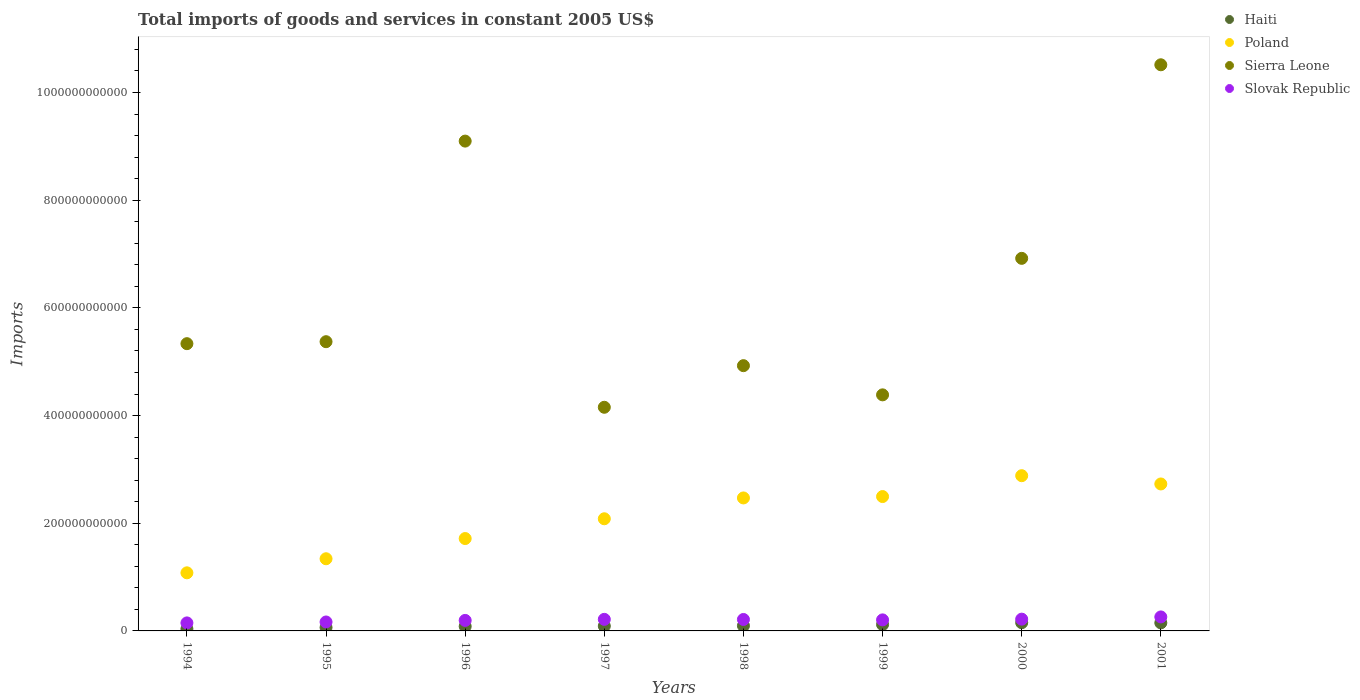What is the total imports of goods and services in Sierra Leone in 1994?
Offer a very short reply. 5.34e+11. Across all years, what is the maximum total imports of goods and services in Poland?
Provide a short and direct response. 2.88e+11. Across all years, what is the minimum total imports of goods and services in Poland?
Your answer should be compact. 1.08e+11. What is the total total imports of goods and services in Poland in the graph?
Provide a short and direct response. 1.68e+12. What is the difference between the total imports of goods and services in Poland in 1998 and that in 2000?
Give a very brief answer. -4.13e+1. What is the difference between the total imports of goods and services in Poland in 1998 and the total imports of goods and services in Slovak Republic in 2000?
Provide a succinct answer. 2.25e+11. What is the average total imports of goods and services in Slovak Republic per year?
Your answer should be compact. 2.03e+1. In the year 1999, what is the difference between the total imports of goods and services in Sierra Leone and total imports of goods and services in Haiti?
Make the answer very short. 4.27e+11. In how many years, is the total imports of goods and services in Slovak Republic greater than 440000000000 US$?
Make the answer very short. 0. What is the ratio of the total imports of goods and services in Poland in 1996 to that in 1997?
Make the answer very short. 0.82. Is the total imports of goods and services in Haiti in 1994 less than that in 1998?
Your answer should be very brief. Yes. What is the difference between the highest and the second highest total imports of goods and services in Poland?
Make the answer very short. 1.54e+1. What is the difference between the highest and the lowest total imports of goods and services in Poland?
Make the answer very short. 1.80e+11. Is it the case that in every year, the sum of the total imports of goods and services in Sierra Leone and total imports of goods and services in Haiti  is greater than the sum of total imports of goods and services in Poland and total imports of goods and services in Slovak Republic?
Offer a very short reply. Yes. Is it the case that in every year, the sum of the total imports of goods and services in Sierra Leone and total imports of goods and services in Poland  is greater than the total imports of goods and services in Slovak Republic?
Make the answer very short. Yes. Does the total imports of goods and services in Haiti monotonically increase over the years?
Provide a succinct answer. No. What is the difference between two consecutive major ticks on the Y-axis?
Offer a terse response. 2.00e+11. Does the graph contain any zero values?
Make the answer very short. No. Does the graph contain grids?
Keep it short and to the point. No. What is the title of the graph?
Make the answer very short. Total imports of goods and services in constant 2005 US$. Does "Canada" appear as one of the legend labels in the graph?
Provide a short and direct response. No. What is the label or title of the X-axis?
Your response must be concise. Years. What is the label or title of the Y-axis?
Ensure brevity in your answer.  Imports. What is the Imports in Haiti in 1994?
Offer a terse response. 3.75e+09. What is the Imports of Poland in 1994?
Ensure brevity in your answer.  1.08e+11. What is the Imports of Sierra Leone in 1994?
Provide a succinct answer. 5.34e+11. What is the Imports of Slovak Republic in 1994?
Give a very brief answer. 1.49e+1. What is the Imports in Haiti in 1995?
Make the answer very short. 6.34e+09. What is the Imports in Poland in 1995?
Your answer should be compact. 1.34e+11. What is the Imports of Sierra Leone in 1995?
Ensure brevity in your answer.  5.37e+11. What is the Imports in Slovak Republic in 1995?
Offer a terse response. 1.66e+1. What is the Imports in Haiti in 1996?
Keep it short and to the point. 8.41e+09. What is the Imports in Poland in 1996?
Ensure brevity in your answer.  1.72e+11. What is the Imports of Sierra Leone in 1996?
Provide a succinct answer. 9.10e+11. What is the Imports in Slovak Republic in 1996?
Provide a succinct answer. 1.95e+1. What is the Imports in Haiti in 1997?
Make the answer very short. 9.02e+09. What is the Imports in Poland in 1997?
Ensure brevity in your answer.  2.08e+11. What is the Imports in Sierra Leone in 1997?
Your answer should be very brief. 4.15e+11. What is the Imports in Slovak Republic in 1997?
Ensure brevity in your answer.  2.15e+1. What is the Imports in Haiti in 1998?
Offer a very short reply. 9.61e+09. What is the Imports of Poland in 1998?
Your answer should be compact. 2.47e+11. What is the Imports of Sierra Leone in 1998?
Offer a terse response. 4.93e+11. What is the Imports in Slovak Republic in 1998?
Ensure brevity in your answer.  2.13e+1. What is the Imports of Haiti in 1999?
Provide a short and direct response. 1.18e+1. What is the Imports of Poland in 1999?
Your response must be concise. 2.50e+11. What is the Imports of Sierra Leone in 1999?
Give a very brief answer. 4.38e+11. What is the Imports in Slovak Republic in 1999?
Keep it short and to the point. 2.05e+1. What is the Imports in Haiti in 2000?
Provide a short and direct response. 1.52e+1. What is the Imports in Poland in 2000?
Your response must be concise. 2.88e+11. What is the Imports in Sierra Leone in 2000?
Give a very brief answer. 6.92e+11. What is the Imports in Slovak Republic in 2000?
Give a very brief answer. 2.19e+1. What is the Imports of Haiti in 2001?
Your answer should be very brief. 1.49e+1. What is the Imports of Poland in 2001?
Offer a very short reply. 2.73e+11. What is the Imports in Sierra Leone in 2001?
Your answer should be very brief. 1.05e+12. What is the Imports of Slovak Republic in 2001?
Keep it short and to the point. 2.60e+1. Across all years, what is the maximum Imports of Haiti?
Offer a very short reply. 1.52e+1. Across all years, what is the maximum Imports of Poland?
Your answer should be very brief. 2.88e+11. Across all years, what is the maximum Imports in Sierra Leone?
Provide a short and direct response. 1.05e+12. Across all years, what is the maximum Imports of Slovak Republic?
Give a very brief answer. 2.60e+1. Across all years, what is the minimum Imports of Haiti?
Keep it short and to the point. 3.75e+09. Across all years, what is the minimum Imports in Poland?
Give a very brief answer. 1.08e+11. Across all years, what is the minimum Imports in Sierra Leone?
Your answer should be very brief. 4.15e+11. Across all years, what is the minimum Imports in Slovak Republic?
Offer a terse response. 1.49e+1. What is the total Imports in Haiti in the graph?
Your response must be concise. 7.91e+1. What is the total Imports of Poland in the graph?
Make the answer very short. 1.68e+12. What is the total Imports of Sierra Leone in the graph?
Offer a terse response. 5.07e+12. What is the total Imports of Slovak Republic in the graph?
Your answer should be compact. 1.62e+11. What is the difference between the Imports in Haiti in 1994 and that in 1995?
Your answer should be very brief. -2.59e+09. What is the difference between the Imports of Poland in 1994 and that in 1995?
Provide a short and direct response. -2.61e+1. What is the difference between the Imports of Sierra Leone in 1994 and that in 1995?
Ensure brevity in your answer.  -3.67e+09. What is the difference between the Imports of Slovak Republic in 1994 and that in 1995?
Your answer should be very brief. -1.73e+09. What is the difference between the Imports in Haiti in 1994 and that in 1996?
Your answer should be compact. -4.66e+09. What is the difference between the Imports in Poland in 1994 and that in 1996?
Your answer should be very brief. -6.37e+1. What is the difference between the Imports in Sierra Leone in 1994 and that in 1996?
Give a very brief answer. -3.76e+11. What is the difference between the Imports in Slovak Republic in 1994 and that in 1996?
Ensure brevity in your answer.  -4.65e+09. What is the difference between the Imports of Haiti in 1994 and that in 1997?
Your answer should be compact. -5.27e+09. What is the difference between the Imports in Poland in 1994 and that in 1997?
Keep it short and to the point. -1.00e+11. What is the difference between the Imports in Sierra Leone in 1994 and that in 1997?
Your answer should be compact. 1.18e+11. What is the difference between the Imports of Slovak Republic in 1994 and that in 1997?
Offer a very short reply. -6.63e+09. What is the difference between the Imports in Haiti in 1994 and that in 1998?
Offer a very short reply. -5.86e+09. What is the difference between the Imports in Poland in 1994 and that in 1998?
Offer a very short reply. -1.39e+11. What is the difference between the Imports in Sierra Leone in 1994 and that in 1998?
Provide a succinct answer. 4.09e+1. What is the difference between the Imports of Slovak Republic in 1994 and that in 1998?
Keep it short and to the point. -6.39e+09. What is the difference between the Imports in Haiti in 1994 and that in 1999?
Offer a terse response. -8.05e+09. What is the difference between the Imports of Poland in 1994 and that in 1999?
Provide a succinct answer. -1.42e+11. What is the difference between the Imports of Sierra Leone in 1994 and that in 1999?
Your answer should be very brief. 9.51e+1. What is the difference between the Imports of Slovak Republic in 1994 and that in 1999?
Keep it short and to the point. -5.63e+09. What is the difference between the Imports in Haiti in 1994 and that in 2000?
Keep it short and to the point. -1.15e+1. What is the difference between the Imports of Poland in 1994 and that in 2000?
Make the answer very short. -1.80e+11. What is the difference between the Imports in Sierra Leone in 1994 and that in 2000?
Your answer should be compact. -1.58e+11. What is the difference between the Imports of Slovak Republic in 1994 and that in 2000?
Give a very brief answer. -6.99e+09. What is the difference between the Imports in Haiti in 1994 and that in 2001?
Your response must be concise. -1.12e+1. What is the difference between the Imports of Poland in 1994 and that in 2001?
Provide a short and direct response. -1.65e+11. What is the difference between the Imports in Sierra Leone in 1994 and that in 2001?
Provide a succinct answer. -5.18e+11. What is the difference between the Imports of Slovak Republic in 1994 and that in 2001?
Offer a very short reply. -1.11e+1. What is the difference between the Imports in Haiti in 1995 and that in 1996?
Make the answer very short. -2.07e+09. What is the difference between the Imports in Poland in 1995 and that in 1996?
Ensure brevity in your answer.  -3.75e+1. What is the difference between the Imports of Sierra Leone in 1995 and that in 1996?
Give a very brief answer. -3.73e+11. What is the difference between the Imports in Slovak Republic in 1995 and that in 1996?
Provide a succinct answer. -2.92e+09. What is the difference between the Imports in Haiti in 1995 and that in 1997?
Your answer should be very brief. -2.67e+09. What is the difference between the Imports of Poland in 1995 and that in 1997?
Ensure brevity in your answer.  -7.43e+1. What is the difference between the Imports in Sierra Leone in 1995 and that in 1997?
Provide a succinct answer. 1.22e+11. What is the difference between the Imports of Slovak Republic in 1995 and that in 1997?
Provide a succinct answer. -4.90e+09. What is the difference between the Imports in Haiti in 1995 and that in 1998?
Your answer should be very brief. -3.27e+09. What is the difference between the Imports in Poland in 1995 and that in 1998?
Make the answer very short. -1.13e+11. What is the difference between the Imports of Sierra Leone in 1995 and that in 1998?
Make the answer very short. 4.45e+1. What is the difference between the Imports of Slovak Republic in 1995 and that in 1998?
Ensure brevity in your answer.  -4.66e+09. What is the difference between the Imports of Haiti in 1995 and that in 1999?
Provide a short and direct response. -5.45e+09. What is the difference between the Imports in Poland in 1995 and that in 1999?
Your answer should be very brief. -1.16e+11. What is the difference between the Imports of Sierra Leone in 1995 and that in 1999?
Keep it short and to the point. 9.87e+1. What is the difference between the Imports of Slovak Republic in 1995 and that in 1999?
Offer a very short reply. -3.90e+09. What is the difference between the Imports in Haiti in 1995 and that in 2000?
Provide a short and direct response. -8.90e+09. What is the difference between the Imports in Poland in 1995 and that in 2000?
Your response must be concise. -1.54e+11. What is the difference between the Imports of Sierra Leone in 1995 and that in 2000?
Offer a terse response. -1.55e+11. What is the difference between the Imports in Slovak Republic in 1995 and that in 2000?
Offer a very short reply. -5.26e+09. What is the difference between the Imports in Haiti in 1995 and that in 2001?
Provide a short and direct response. -8.59e+09. What is the difference between the Imports in Poland in 1995 and that in 2001?
Make the answer very short. -1.39e+11. What is the difference between the Imports of Sierra Leone in 1995 and that in 2001?
Ensure brevity in your answer.  -5.14e+11. What is the difference between the Imports in Slovak Republic in 1995 and that in 2001?
Offer a very short reply. -9.40e+09. What is the difference between the Imports of Haiti in 1996 and that in 1997?
Offer a very short reply. -6.07e+08. What is the difference between the Imports of Poland in 1996 and that in 1997?
Give a very brief answer. -3.67e+1. What is the difference between the Imports of Sierra Leone in 1996 and that in 1997?
Your answer should be very brief. 4.94e+11. What is the difference between the Imports of Slovak Republic in 1996 and that in 1997?
Your answer should be very brief. -1.98e+09. What is the difference between the Imports in Haiti in 1996 and that in 1998?
Give a very brief answer. -1.20e+09. What is the difference between the Imports in Poland in 1996 and that in 1998?
Provide a short and direct response. -7.54e+1. What is the difference between the Imports in Sierra Leone in 1996 and that in 1998?
Keep it short and to the point. 4.17e+11. What is the difference between the Imports of Slovak Republic in 1996 and that in 1998?
Ensure brevity in your answer.  -1.74e+09. What is the difference between the Imports of Haiti in 1996 and that in 1999?
Provide a succinct answer. -3.38e+09. What is the difference between the Imports in Poland in 1996 and that in 1999?
Your response must be concise. -7.80e+1. What is the difference between the Imports of Sierra Leone in 1996 and that in 1999?
Your answer should be very brief. 4.71e+11. What is the difference between the Imports of Slovak Republic in 1996 and that in 1999?
Your response must be concise. -9.83e+08. What is the difference between the Imports of Haiti in 1996 and that in 2000?
Provide a succinct answer. -6.84e+09. What is the difference between the Imports of Poland in 1996 and that in 2000?
Offer a very short reply. -1.17e+11. What is the difference between the Imports of Sierra Leone in 1996 and that in 2000?
Provide a succinct answer. 2.18e+11. What is the difference between the Imports of Slovak Republic in 1996 and that in 2000?
Your answer should be compact. -2.34e+09. What is the difference between the Imports in Haiti in 1996 and that in 2001?
Keep it short and to the point. -6.52e+09. What is the difference between the Imports of Poland in 1996 and that in 2001?
Offer a very short reply. -1.01e+11. What is the difference between the Imports in Sierra Leone in 1996 and that in 2001?
Keep it short and to the point. -1.42e+11. What is the difference between the Imports of Slovak Republic in 1996 and that in 2001?
Your answer should be very brief. -6.48e+09. What is the difference between the Imports of Haiti in 1997 and that in 1998?
Your response must be concise. -5.95e+08. What is the difference between the Imports of Poland in 1997 and that in 1998?
Your answer should be very brief. -3.87e+1. What is the difference between the Imports in Sierra Leone in 1997 and that in 1998?
Offer a terse response. -7.73e+1. What is the difference between the Imports in Slovak Republic in 1997 and that in 1998?
Ensure brevity in your answer.  2.36e+08. What is the difference between the Imports of Haiti in 1997 and that in 1999?
Your answer should be very brief. -2.78e+09. What is the difference between the Imports in Poland in 1997 and that in 1999?
Ensure brevity in your answer.  -4.13e+1. What is the difference between the Imports in Sierra Leone in 1997 and that in 1999?
Offer a terse response. -2.31e+1. What is the difference between the Imports of Slovak Republic in 1997 and that in 1999?
Provide a succinct answer. 9.95e+08. What is the difference between the Imports in Haiti in 1997 and that in 2000?
Provide a succinct answer. -6.23e+09. What is the difference between the Imports of Poland in 1997 and that in 2000?
Offer a very short reply. -8.00e+1. What is the difference between the Imports in Sierra Leone in 1997 and that in 2000?
Provide a short and direct response. -2.77e+11. What is the difference between the Imports of Slovak Republic in 1997 and that in 2000?
Make the answer very short. -3.59e+08. What is the difference between the Imports in Haiti in 1997 and that in 2001?
Provide a succinct answer. -5.91e+09. What is the difference between the Imports in Poland in 1997 and that in 2001?
Provide a succinct answer. -6.46e+1. What is the difference between the Imports of Sierra Leone in 1997 and that in 2001?
Your answer should be very brief. -6.36e+11. What is the difference between the Imports of Slovak Republic in 1997 and that in 2001?
Your response must be concise. -4.50e+09. What is the difference between the Imports of Haiti in 1998 and that in 1999?
Your answer should be compact. -2.18e+09. What is the difference between the Imports of Poland in 1998 and that in 1999?
Keep it short and to the point. -2.57e+09. What is the difference between the Imports in Sierra Leone in 1998 and that in 1999?
Give a very brief answer. 5.42e+1. What is the difference between the Imports in Slovak Republic in 1998 and that in 1999?
Give a very brief answer. 7.59e+08. What is the difference between the Imports of Haiti in 1998 and that in 2000?
Ensure brevity in your answer.  -5.64e+09. What is the difference between the Imports of Poland in 1998 and that in 2000?
Ensure brevity in your answer.  -4.13e+1. What is the difference between the Imports of Sierra Leone in 1998 and that in 2000?
Your response must be concise. -1.99e+11. What is the difference between the Imports of Slovak Republic in 1998 and that in 2000?
Give a very brief answer. -5.95e+08. What is the difference between the Imports in Haiti in 1998 and that in 2001?
Your response must be concise. -5.32e+09. What is the difference between the Imports in Poland in 1998 and that in 2001?
Give a very brief answer. -2.60e+1. What is the difference between the Imports of Sierra Leone in 1998 and that in 2001?
Make the answer very short. -5.59e+11. What is the difference between the Imports in Slovak Republic in 1998 and that in 2001?
Your answer should be very brief. -4.74e+09. What is the difference between the Imports of Haiti in 1999 and that in 2000?
Keep it short and to the point. -3.45e+09. What is the difference between the Imports in Poland in 1999 and that in 2000?
Provide a succinct answer. -3.87e+1. What is the difference between the Imports of Sierra Leone in 1999 and that in 2000?
Provide a succinct answer. -2.54e+11. What is the difference between the Imports in Slovak Republic in 1999 and that in 2000?
Your answer should be very brief. -1.35e+09. What is the difference between the Imports of Haiti in 1999 and that in 2001?
Offer a very short reply. -3.14e+09. What is the difference between the Imports in Poland in 1999 and that in 2001?
Offer a very short reply. -2.34e+1. What is the difference between the Imports in Sierra Leone in 1999 and that in 2001?
Give a very brief answer. -6.13e+11. What is the difference between the Imports of Slovak Republic in 1999 and that in 2001?
Your answer should be compact. -5.50e+09. What is the difference between the Imports of Haiti in 2000 and that in 2001?
Ensure brevity in your answer.  3.17e+08. What is the difference between the Imports in Poland in 2000 and that in 2001?
Give a very brief answer. 1.54e+1. What is the difference between the Imports in Sierra Leone in 2000 and that in 2001?
Make the answer very short. -3.60e+11. What is the difference between the Imports in Slovak Republic in 2000 and that in 2001?
Provide a short and direct response. -4.14e+09. What is the difference between the Imports in Haiti in 1994 and the Imports in Poland in 1995?
Give a very brief answer. -1.30e+11. What is the difference between the Imports of Haiti in 1994 and the Imports of Sierra Leone in 1995?
Provide a succinct answer. -5.33e+11. What is the difference between the Imports in Haiti in 1994 and the Imports in Slovak Republic in 1995?
Ensure brevity in your answer.  -1.29e+1. What is the difference between the Imports of Poland in 1994 and the Imports of Sierra Leone in 1995?
Make the answer very short. -4.29e+11. What is the difference between the Imports of Poland in 1994 and the Imports of Slovak Republic in 1995?
Keep it short and to the point. 9.13e+1. What is the difference between the Imports of Sierra Leone in 1994 and the Imports of Slovak Republic in 1995?
Your answer should be very brief. 5.17e+11. What is the difference between the Imports of Haiti in 1994 and the Imports of Poland in 1996?
Ensure brevity in your answer.  -1.68e+11. What is the difference between the Imports of Haiti in 1994 and the Imports of Sierra Leone in 1996?
Provide a short and direct response. -9.06e+11. What is the difference between the Imports in Haiti in 1994 and the Imports in Slovak Republic in 1996?
Offer a very short reply. -1.58e+1. What is the difference between the Imports in Poland in 1994 and the Imports in Sierra Leone in 1996?
Offer a very short reply. -8.02e+11. What is the difference between the Imports of Poland in 1994 and the Imports of Slovak Republic in 1996?
Your answer should be very brief. 8.84e+1. What is the difference between the Imports in Sierra Leone in 1994 and the Imports in Slovak Republic in 1996?
Your response must be concise. 5.14e+11. What is the difference between the Imports of Haiti in 1994 and the Imports of Poland in 1997?
Offer a very short reply. -2.05e+11. What is the difference between the Imports of Haiti in 1994 and the Imports of Sierra Leone in 1997?
Your answer should be compact. -4.12e+11. What is the difference between the Imports in Haiti in 1994 and the Imports in Slovak Republic in 1997?
Keep it short and to the point. -1.77e+1. What is the difference between the Imports of Poland in 1994 and the Imports of Sierra Leone in 1997?
Your answer should be compact. -3.07e+11. What is the difference between the Imports in Poland in 1994 and the Imports in Slovak Republic in 1997?
Your response must be concise. 8.64e+1. What is the difference between the Imports of Sierra Leone in 1994 and the Imports of Slovak Republic in 1997?
Your response must be concise. 5.12e+11. What is the difference between the Imports in Haiti in 1994 and the Imports in Poland in 1998?
Provide a short and direct response. -2.43e+11. What is the difference between the Imports in Haiti in 1994 and the Imports in Sierra Leone in 1998?
Offer a terse response. -4.89e+11. What is the difference between the Imports in Haiti in 1994 and the Imports in Slovak Republic in 1998?
Your response must be concise. -1.75e+1. What is the difference between the Imports of Poland in 1994 and the Imports of Sierra Leone in 1998?
Your answer should be compact. -3.85e+11. What is the difference between the Imports of Poland in 1994 and the Imports of Slovak Republic in 1998?
Give a very brief answer. 8.66e+1. What is the difference between the Imports of Sierra Leone in 1994 and the Imports of Slovak Republic in 1998?
Provide a succinct answer. 5.12e+11. What is the difference between the Imports of Haiti in 1994 and the Imports of Poland in 1999?
Ensure brevity in your answer.  -2.46e+11. What is the difference between the Imports in Haiti in 1994 and the Imports in Sierra Leone in 1999?
Give a very brief answer. -4.35e+11. What is the difference between the Imports in Haiti in 1994 and the Imports in Slovak Republic in 1999?
Your response must be concise. -1.68e+1. What is the difference between the Imports of Poland in 1994 and the Imports of Sierra Leone in 1999?
Offer a very short reply. -3.31e+11. What is the difference between the Imports in Poland in 1994 and the Imports in Slovak Republic in 1999?
Provide a succinct answer. 8.74e+1. What is the difference between the Imports of Sierra Leone in 1994 and the Imports of Slovak Republic in 1999?
Your answer should be compact. 5.13e+11. What is the difference between the Imports in Haiti in 1994 and the Imports in Poland in 2000?
Give a very brief answer. -2.85e+11. What is the difference between the Imports of Haiti in 1994 and the Imports of Sierra Leone in 2000?
Offer a terse response. -6.88e+11. What is the difference between the Imports of Haiti in 1994 and the Imports of Slovak Republic in 2000?
Offer a very short reply. -1.81e+1. What is the difference between the Imports of Poland in 1994 and the Imports of Sierra Leone in 2000?
Give a very brief answer. -5.84e+11. What is the difference between the Imports in Poland in 1994 and the Imports in Slovak Republic in 2000?
Offer a very short reply. 8.60e+1. What is the difference between the Imports in Sierra Leone in 1994 and the Imports in Slovak Republic in 2000?
Offer a terse response. 5.12e+11. What is the difference between the Imports of Haiti in 1994 and the Imports of Poland in 2001?
Your answer should be very brief. -2.69e+11. What is the difference between the Imports in Haiti in 1994 and the Imports in Sierra Leone in 2001?
Offer a very short reply. -1.05e+12. What is the difference between the Imports of Haiti in 1994 and the Imports of Slovak Republic in 2001?
Your response must be concise. -2.22e+1. What is the difference between the Imports of Poland in 1994 and the Imports of Sierra Leone in 2001?
Offer a very short reply. -9.44e+11. What is the difference between the Imports in Poland in 1994 and the Imports in Slovak Republic in 2001?
Provide a succinct answer. 8.19e+1. What is the difference between the Imports of Sierra Leone in 1994 and the Imports of Slovak Republic in 2001?
Provide a short and direct response. 5.08e+11. What is the difference between the Imports in Haiti in 1995 and the Imports in Poland in 1996?
Give a very brief answer. -1.65e+11. What is the difference between the Imports of Haiti in 1995 and the Imports of Sierra Leone in 1996?
Ensure brevity in your answer.  -9.03e+11. What is the difference between the Imports of Haiti in 1995 and the Imports of Slovak Republic in 1996?
Offer a very short reply. -1.32e+1. What is the difference between the Imports of Poland in 1995 and the Imports of Sierra Leone in 1996?
Make the answer very short. -7.76e+11. What is the difference between the Imports in Poland in 1995 and the Imports in Slovak Republic in 1996?
Offer a terse response. 1.15e+11. What is the difference between the Imports in Sierra Leone in 1995 and the Imports in Slovak Republic in 1996?
Offer a terse response. 5.18e+11. What is the difference between the Imports of Haiti in 1995 and the Imports of Poland in 1997?
Your answer should be compact. -2.02e+11. What is the difference between the Imports of Haiti in 1995 and the Imports of Sierra Leone in 1997?
Provide a short and direct response. -4.09e+11. What is the difference between the Imports in Haiti in 1995 and the Imports in Slovak Republic in 1997?
Give a very brief answer. -1.52e+1. What is the difference between the Imports of Poland in 1995 and the Imports of Sierra Leone in 1997?
Provide a short and direct response. -2.81e+11. What is the difference between the Imports of Poland in 1995 and the Imports of Slovak Republic in 1997?
Provide a succinct answer. 1.13e+11. What is the difference between the Imports of Sierra Leone in 1995 and the Imports of Slovak Republic in 1997?
Your response must be concise. 5.16e+11. What is the difference between the Imports of Haiti in 1995 and the Imports of Poland in 1998?
Provide a short and direct response. -2.41e+11. What is the difference between the Imports in Haiti in 1995 and the Imports in Sierra Leone in 1998?
Ensure brevity in your answer.  -4.86e+11. What is the difference between the Imports of Haiti in 1995 and the Imports of Slovak Republic in 1998?
Keep it short and to the point. -1.49e+1. What is the difference between the Imports in Poland in 1995 and the Imports in Sierra Leone in 1998?
Your response must be concise. -3.59e+11. What is the difference between the Imports in Poland in 1995 and the Imports in Slovak Republic in 1998?
Your answer should be very brief. 1.13e+11. What is the difference between the Imports in Sierra Leone in 1995 and the Imports in Slovak Republic in 1998?
Ensure brevity in your answer.  5.16e+11. What is the difference between the Imports of Haiti in 1995 and the Imports of Poland in 1999?
Provide a short and direct response. -2.43e+11. What is the difference between the Imports in Haiti in 1995 and the Imports in Sierra Leone in 1999?
Give a very brief answer. -4.32e+11. What is the difference between the Imports of Haiti in 1995 and the Imports of Slovak Republic in 1999?
Offer a terse response. -1.42e+1. What is the difference between the Imports in Poland in 1995 and the Imports in Sierra Leone in 1999?
Give a very brief answer. -3.04e+11. What is the difference between the Imports in Poland in 1995 and the Imports in Slovak Republic in 1999?
Offer a terse response. 1.14e+11. What is the difference between the Imports in Sierra Leone in 1995 and the Imports in Slovak Republic in 1999?
Provide a short and direct response. 5.17e+11. What is the difference between the Imports of Haiti in 1995 and the Imports of Poland in 2000?
Give a very brief answer. -2.82e+11. What is the difference between the Imports in Haiti in 1995 and the Imports in Sierra Leone in 2000?
Your answer should be compact. -6.86e+11. What is the difference between the Imports in Haiti in 1995 and the Imports in Slovak Republic in 2000?
Give a very brief answer. -1.55e+1. What is the difference between the Imports in Poland in 1995 and the Imports in Sierra Leone in 2000?
Offer a very short reply. -5.58e+11. What is the difference between the Imports in Poland in 1995 and the Imports in Slovak Republic in 2000?
Provide a succinct answer. 1.12e+11. What is the difference between the Imports in Sierra Leone in 1995 and the Imports in Slovak Republic in 2000?
Your answer should be compact. 5.15e+11. What is the difference between the Imports in Haiti in 1995 and the Imports in Poland in 2001?
Provide a succinct answer. -2.67e+11. What is the difference between the Imports of Haiti in 1995 and the Imports of Sierra Leone in 2001?
Keep it short and to the point. -1.05e+12. What is the difference between the Imports of Haiti in 1995 and the Imports of Slovak Republic in 2001?
Ensure brevity in your answer.  -1.97e+1. What is the difference between the Imports in Poland in 1995 and the Imports in Sierra Leone in 2001?
Keep it short and to the point. -9.17e+11. What is the difference between the Imports of Poland in 1995 and the Imports of Slovak Republic in 2001?
Ensure brevity in your answer.  1.08e+11. What is the difference between the Imports in Sierra Leone in 1995 and the Imports in Slovak Republic in 2001?
Make the answer very short. 5.11e+11. What is the difference between the Imports in Haiti in 1996 and the Imports in Poland in 1997?
Offer a very short reply. -2.00e+11. What is the difference between the Imports in Haiti in 1996 and the Imports in Sierra Leone in 1997?
Your response must be concise. -4.07e+11. What is the difference between the Imports of Haiti in 1996 and the Imports of Slovak Republic in 1997?
Your answer should be compact. -1.31e+1. What is the difference between the Imports in Poland in 1996 and the Imports in Sierra Leone in 1997?
Provide a short and direct response. -2.44e+11. What is the difference between the Imports of Poland in 1996 and the Imports of Slovak Republic in 1997?
Your answer should be compact. 1.50e+11. What is the difference between the Imports of Sierra Leone in 1996 and the Imports of Slovak Republic in 1997?
Your response must be concise. 8.88e+11. What is the difference between the Imports of Haiti in 1996 and the Imports of Poland in 1998?
Give a very brief answer. -2.39e+11. What is the difference between the Imports in Haiti in 1996 and the Imports in Sierra Leone in 1998?
Offer a terse response. -4.84e+11. What is the difference between the Imports in Haiti in 1996 and the Imports in Slovak Republic in 1998?
Your answer should be compact. -1.29e+1. What is the difference between the Imports of Poland in 1996 and the Imports of Sierra Leone in 1998?
Keep it short and to the point. -3.21e+11. What is the difference between the Imports of Poland in 1996 and the Imports of Slovak Republic in 1998?
Ensure brevity in your answer.  1.50e+11. What is the difference between the Imports in Sierra Leone in 1996 and the Imports in Slovak Republic in 1998?
Your answer should be compact. 8.88e+11. What is the difference between the Imports of Haiti in 1996 and the Imports of Poland in 1999?
Give a very brief answer. -2.41e+11. What is the difference between the Imports in Haiti in 1996 and the Imports in Sierra Leone in 1999?
Give a very brief answer. -4.30e+11. What is the difference between the Imports in Haiti in 1996 and the Imports in Slovak Republic in 1999?
Give a very brief answer. -1.21e+1. What is the difference between the Imports of Poland in 1996 and the Imports of Sierra Leone in 1999?
Provide a succinct answer. -2.67e+11. What is the difference between the Imports of Poland in 1996 and the Imports of Slovak Republic in 1999?
Make the answer very short. 1.51e+11. What is the difference between the Imports of Sierra Leone in 1996 and the Imports of Slovak Republic in 1999?
Make the answer very short. 8.89e+11. What is the difference between the Imports of Haiti in 1996 and the Imports of Poland in 2000?
Provide a succinct answer. -2.80e+11. What is the difference between the Imports in Haiti in 1996 and the Imports in Sierra Leone in 2000?
Provide a short and direct response. -6.84e+11. What is the difference between the Imports in Haiti in 1996 and the Imports in Slovak Republic in 2000?
Provide a short and direct response. -1.34e+1. What is the difference between the Imports of Poland in 1996 and the Imports of Sierra Leone in 2000?
Your answer should be compact. -5.20e+11. What is the difference between the Imports of Poland in 1996 and the Imports of Slovak Republic in 2000?
Offer a very short reply. 1.50e+11. What is the difference between the Imports in Sierra Leone in 1996 and the Imports in Slovak Republic in 2000?
Provide a short and direct response. 8.88e+11. What is the difference between the Imports of Haiti in 1996 and the Imports of Poland in 2001?
Your response must be concise. -2.65e+11. What is the difference between the Imports in Haiti in 1996 and the Imports in Sierra Leone in 2001?
Keep it short and to the point. -1.04e+12. What is the difference between the Imports in Haiti in 1996 and the Imports in Slovak Republic in 2001?
Your answer should be compact. -1.76e+1. What is the difference between the Imports in Poland in 1996 and the Imports in Sierra Leone in 2001?
Give a very brief answer. -8.80e+11. What is the difference between the Imports in Poland in 1996 and the Imports in Slovak Republic in 2001?
Provide a short and direct response. 1.46e+11. What is the difference between the Imports of Sierra Leone in 1996 and the Imports of Slovak Republic in 2001?
Offer a terse response. 8.84e+11. What is the difference between the Imports of Haiti in 1997 and the Imports of Poland in 1998?
Your answer should be very brief. -2.38e+11. What is the difference between the Imports of Haiti in 1997 and the Imports of Sierra Leone in 1998?
Give a very brief answer. -4.84e+11. What is the difference between the Imports in Haiti in 1997 and the Imports in Slovak Republic in 1998?
Ensure brevity in your answer.  -1.22e+1. What is the difference between the Imports of Poland in 1997 and the Imports of Sierra Leone in 1998?
Offer a very short reply. -2.84e+11. What is the difference between the Imports in Poland in 1997 and the Imports in Slovak Republic in 1998?
Give a very brief answer. 1.87e+11. What is the difference between the Imports of Sierra Leone in 1997 and the Imports of Slovak Republic in 1998?
Make the answer very short. 3.94e+11. What is the difference between the Imports in Haiti in 1997 and the Imports in Poland in 1999?
Offer a very short reply. -2.41e+11. What is the difference between the Imports of Haiti in 1997 and the Imports of Sierra Leone in 1999?
Make the answer very short. -4.29e+11. What is the difference between the Imports in Haiti in 1997 and the Imports in Slovak Republic in 1999?
Keep it short and to the point. -1.15e+1. What is the difference between the Imports in Poland in 1997 and the Imports in Sierra Leone in 1999?
Provide a succinct answer. -2.30e+11. What is the difference between the Imports of Poland in 1997 and the Imports of Slovak Republic in 1999?
Give a very brief answer. 1.88e+11. What is the difference between the Imports of Sierra Leone in 1997 and the Imports of Slovak Republic in 1999?
Your response must be concise. 3.95e+11. What is the difference between the Imports in Haiti in 1997 and the Imports in Poland in 2000?
Offer a very short reply. -2.79e+11. What is the difference between the Imports of Haiti in 1997 and the Imports of Sierra Leone in 2000?
Give a very brief answer. -6.83e+11. What is the difference between the Imports in Haiti in 1997 and the Imports in Slovak Republic in 2000?
Offer a terse response. -1.28e+1. What is the difference between the Imports of Poland in 1997 and the Imports of Sierra Leone in 2000?
Give a very brief answer. -4.84e+11. What is the difference between the Imports of Poland in 1997 and the Imports of Slovak Republic in 2000?
Your answer should be very brief. 1.86e+11. What is the difference between the Imports in Sierra Leone in 1997 and the Imports in Slovak Republic in 2000?
Your answer should be very brief. 3.94e+11. What is the difference between the Imports of Haiti in 1997 and the Imports of Poland in 2001?
Make the answer very short. -2.64e+11. What is the difference between the Imports of Haiti in 1997 and the Imports of Sierra Leone in 2001?
Provide a succinct answer. -1.04e+12. What is the difference between the Imports in Haiti in 1997 and the Imports in Slovak Republic in 2001?
Keep it short and to the point. -1.70e+1. What is the difference between the Imports of Poland in 1997 and the Imports of Sierra Leone in 2001?
Offer a terse response. -8.43e+11. What is the difference between the Imports of Poland in 1997 and the Imports of Slovak Republic in 2001?
Offer a very short reply. 1.82e+11. What is the difference between the Imports in Sierra Leone in 1997 and the Imports in Slovak Republic in 2001?
Offer a terse response. 3.89e+11. What is the difference between the Imports in Haiti in 1998 and the Imports in Poland in 1999?
Offer a terse response. -2.40e+11. What is the difference between the Imports in Haiti in 1998 and the Imports in Sierra Leone in 1999?
Give a very brief answer. -4.29e+11. What is the difference between the Imports of Haiti in 1998 and the Imports of Slovak Republic in 1999?
Make the answer very short. -1.09e+1. What is the difference between the Imports in Poland in 1998 and the Imports in Sierra Leone in 1999?
Give a very brief answer. -1.91e+11. What is the difference between the Imports of Poland in 1998 and the Imports of Slovak Republic in 1999?
Your response must be concise. 2.26e+11. What is the difference between the Imports in Sierra Leone in 1998 and the Imports in Slovak Republic in 1999?
Offer a terse response. 4.72e+11. What is the difference between the Imports in Haiti in 1998 and the Imports in Poland in 2000?
Offer a terse response. -2.79e+11. What is the difference between the Imports in Haiti in 1998 and the Imports in Sierra Leone in 2000?
Provide a succinct answer. -6.82e+11. What is the difference between the Imports of Haiti in 1998 and the Imports of Slovak Republic in 2000?
Provide a succinct answer. -1.22e+1. What is the difference between the Imports in Poland in 1998 and the Imports in Sierra Leone in 2000?
Offer a very short reply. -4.45e+11. What is the difference between the Imports of Poland in 1998 and the Imports of Slovak Republic in 2000?
Offer a very short reply. 2.25e+11. What is the difference between the Imports of Sierra Leone in 1998 and the Imports of Slovak Republic in 2000?
Provide a short and direct response. 4.71e+11. What is the difference between the Imports in Haiti in 1998 and the Imports in Poland in 2001?
Offer a terse response. -2.63e+11. What is the difference between the Imports in Haiti in 1998 and the Imports in Sierra Leone in 2001?
Make the answer very short. -1.04e+12. What is the difference between the Imports of Haiti in 1998 and the Imports of Slovak Republic in 2001?
Your answer should be compact. -1.64e+1. What is the difference between the Imports in Poland in 1998 and the Imports in Sierra Leone in 2001?
Offer a very short reply. -8.05e+11. What is the difference between the Imports of Poland in 1998 and the Imports of Slovak Republic in 2001?
Offer a terse response. 2.21e+11. What is the difference between the Imports in Sierra Leone in 1998 and the Imports in Slovak Republic in 2001?
Your response must be concise. 4.67e+11. What is the difference between the Imports of Haiti in 1999 and the Imports of Poland in 2000?
Provide a succinct answer. -2.77e+11. What is the difference between the Imports of Haiti in 1999 and the Imports of Sierra Leone in 2000?
Your response must be concise. -6.80e+11. What is the difference between the Imports in Haiti in 1999 and the Imports in Slovak Republic in 2000?
Your answer should be very brief. -1.01e+1. What is the difference between the Imports in Poland in 1999 and the Imports in Sierra Leone in 2000?
Make the answer very short. -4.42e+11. What is the difference between the Imports in Poland in 1999 and the Imports in Slovak Republic in 2000?
Offer a very short reply. 2.28e+11. What is the difference between the Imports of Sierra Leone in 1999 and the Imports of Slovak Republic in 2000?
Keep it short and to the point. 4.17e+11. What is the difference between the Imports in Haiti in 1999 and the Imports in Poland in 2001?
Your answer should be very brief. -2.61e+11. What is the difference between the Imports in Haiti in 1999 and the Imports in Sierra Leone in 2001?
Your answer should be very brief. -1.04e+12. What is the difference between the Imports of Haiti in 1999 and the Imports of Slovak Republic in 2001?
Make the answer very short. -1.42e+1. What is the difference between the Imports in Poland in 1999 and the Imports in Sierra Leone in 2001?
Offer a terse response. -8.02e+11. What is the difference between the Imports in Poland in 1999 and the Imports in Slovak Republic in 2001?
Ensure brevity in your answer.  2.24e+11. What is the difference between the Imports of Sierra Leone in 1999 and the Imports of Slovak Republic in 2001?
Your response must be concise. 4.12e+11. What is the difference between the Imports of Haiti in 2000 and the Imports of Poland in 2001?
Your answer should be very brief. -2.58e+11. What is the difference between the Imports in Haiti in 2000 and the Imports in Sierra Leone in 2001?
Your answer should be very brief. -1.04e+12. What is the difference between the Imports in Haiti in 2000 and the Imports in Slovak Republic in 2001?
Offer a terse response. -1.08e+1. What is the difference between the Imports of Poland in 2000 and the Imports of Sierra Leone in 2001?
Offer a terse response. -7.63e+11. What is the difference between the Imports in Poland in 2000 and the Imports in Slovak Republic in 2001?
Make the answer very short. 2.62e+11. What is the difference between the Imports of Sierra Leone in 2000 and the Imports of Slovak Republic in 2001?
Offer a very short reply. 6.66e+11. What is the average Imports in Haiti per year?
Give a very brief answer. 9.89e+09. What is the average Imports in Poland per year?
Offer a terse response. 2.10e+11. What is the average Imports of Sierra Leone per year?
Offer a very short reply. 6.34e+11. What is the average Imports in Slovak Republic per year?
Give a very brief answer. 2.03e+1. In the year 1994, what is the difference between the Imports of Haiti and Imports of Poland?
Keep it short and to the point. -1.04e+11. In the year 1994, what is the difference between the Imports in Haiti and Imports in Sierra Leone?
Provide a succinct answer. -5.30e+11. In the year 1994, what is the difference between the Imports of Haiti and Imports of Slovak Republic?
Provide a short and direct response. -1.11e+1. In the year 1994, what is the difference between the Imports in Poland and Imports in Sierra Leone?
Keep it short and to the point. -4.26e+11. In the year 1994, what is the difference between the Imports of Poland and Imports of Slovak Republic?
Your response must be concise. 9.30e+1. In the year 1994, what is the difference between the Imports of Sierra Leone and Imports of Slovak Republic?
Offer a very short reply. 5.19e+11. In the year 1995, what is the difference between the Imports in Haiti and Imports in Poland?
Your answer should be compact. -1.28e+11. In the year 1995, what is the difference between the Imports in Haiti and Imports in Sierra Leone?
Ensure brevity in your answer.  -5.31e+11. In the year 1995, what is the difference between the Imports in Haiti and Imports in Slovak Republic?
Provide a succinct answer. -1.03e+1. In the year 1995, what is the difference between the Imports of Poland and Imports of Sierra Leone?
Your answer should be very brief. -4.03e+11. In the year 1995, what is the difference between the Imports of Poland and Imports of Slovak Republic?
Make the answer very short. 1.17e+11. In the year 1995, what is the difference between the Imports of Sierra Leone and Imports of Slovak Republic?
Provide a short and direct response. 5.21e+11. In the year 1996, what is the difference between the Imports in Haiti and Imports in Poland?
Give a very brief answer. -1.63e+11. In the year 1996, what is the difference between the Imports in Haiti and Imports in Sierra Leone?
Provide a short and direct response. -9.01e+11. In the year 1996, what is the difference between the Imports in Haiti and Imports in Slovak Republic?
Your response must be concise. -1.11e+1. In the year 1996, what is the difference between the Imports of Poland and Imports of Sierra Leone?
Keep it short and to the point. -7.38e+11. In the year 1996, what is the difference between the Imports of Poland and Imports of Slovak Republic?
Provide a succinct answer. 1.52e+11. In the year 1996, what is the difference between the Imports of Sierra Leone and Imports of Slovak Republic?
Ensure brevity in your answer.  8.90e+11. In the year 1997, what is the difference between the Imports in Haiti and Imports in Poland?
Make the answer very short. -1.99e+11. In the year 1997, what is the difference between the Imports of Haiti and Imports of Sierra Leone?
Give a very brief answer. -4.06e+11. In the year 1997, what is the difference between the Imports of Haiti and Imports of Slovak Republic?
Provide a succinct answer. -1.25e+1. In the year 1997, what is the difference between the Imports of Poland and Imports of Sierra Leone?
Offer a very short reply. -2.07e+11. In the year 1997, what is the difference between the Imports of Poland and Imports of Slovak Republic?
Make the answer very short. 1.87e+11. In the year 1997, what is the difference between the Imports in Sierra Leone and Imports in Slovak Republic?
Your answer should be compact. 3.94e+11. In the year 1998, what is the difference between the Imports of Haiti and Imports of Poland?
Keep it short and to the point. -2.37e+11. In the year 1998, what is the difference between the Imports in Haiti and Imports in Sierra Leone?
Give a very brief answer. -4.83e+11. In the year 1998, what is the difference between the Imports of Haiti and Imports of Slovak Republic?
Provide a short and direct response. -1.17e+1. In the year 1998, what is the difference between the Imports in Poland and Imports in Sierra Leone?
Offer a very short reply. -2.46e+11. In the year 1998, what is the difference between the Imports in Poland and Imports in Slovak Republic?
Your answer should be very brief. 2.26e+11. In the year 1998, what is the difference between the Imports of Sierra Leone and Imports of Slovak Republic?
Your answer should be very brief. 4.71e+11. In the year 1999, what is the difference between the Imports in Haiti and Imports in Poland?
Make the answer very short. -2.38e+11. In the year 1999, what is the difference between the Imports of Haiti and Imports of Sierra Leone?
Ensure brevity in your answer.  -4.27e+11. In the year 1999, what is the difference between the Imports in Haiti and Imports in Slovak Republic?
Provide a succinct answer. -8.71e+09. In the year 1999, what is the difference between the Imports in Poland and Imports in Sierra Leone?
Ensure brevity in your answer.  -1.89e+11. In the year 1999, what is the difference between the Imports in Poland and Imports in Slovak Republic?
Offer a terse response. 2.29e+11. In the year 1999, what is the difference between the Imports in Sierra Leone and Imports in Slovak Republic?
Offer a terse response. 4.18e+11. In the year 2000, what is the difference between the Imports of Haiti and Imports of Poland?
Your response must be concise. -2.73e+11. In the year 2000, what is the difference between the Imports in Haiti and Imports in Sierra Leone?
Ensure brevity in your answer.  -6.77e+11. In the year 2000, what is the difference between the Imports of Haiti and Imports of Slovak Republic?
Your response must be concise. -6.61e+09. In the year 2000, what is the difference between the Imports in Poland and Imports in Sierra Leone?
Your answer should be very brief. -4.04e+11. In the year 2000, what is the difference between the Imports of Poland and Imports of Slovak Republic?
Keep it short and to the point. 2.66e+11. In the year 2000, what is the difference between the Imports in Sierra Leone and Imports in Slovak Republic?
Your answer should be compact. 6.70e+11. In the year 2001, what is the difference between the Imports of Haiti and Imports of Poland?
Give a very brief answer. -2.58e+11. In the year 2001, what is the difference between the Imports in Haiti and Imports in Sierra Leone?
Your response must be concise. -1.04e+12. In the year 2001, what is the difference between the Imports in Haiti and Imports in Slovak Republic?
Your response must be concise. -1.11e+1. In the year 2001, what is the difference between the Imports in Poland and Imports in Sierra Leone?
Offer a very short reply. -7.79e+11. In the year 2001, what is the difference between the Imports of Poland and Imports of Slovak Republic?
Your answer should be very brief. 2.47e+11. In the year 2001, what is the difference between the Imports of Sierra Leone and Imports of Slovak Republic?
Keep it short and to the point. 1.03e+12. What is the ratio of the Imports in Haiti in 1994 to that in 1995?
Offer a terse response. 0.59. What is the ratio of the Imports in Poland in 1994 to that in 1995?
Your answer should be compact. 0.81. What is the ratio of the Imports in Slovak Republic in 1994 to that in 1995?
Give a very brief answer. 0.9. What is the ratio of the Imports in Haiti in 1994 to that in 1996?
Offer a terse response. 0.45. What is the ratio of the Imports of Poland in 1994 to that in 1996?
Your answer should be compact. 0.63. What is the ratio of the Imports of Sierra Leone in 1994 to that in 1996?
Ensure brevity in your answer.  0.59. What is the ratio of the Imports of Slovak Republic in 1994 to that in 1996?
Keep it short and to the point. 0.76. What is the ratio of the Imports of Haiti in 1994 to that in 1997?
Offer a very short reply. 0.42. What is the ratio of the Imports in Poland in 1994 to that in 1997?
Your response must be concise. 0.52. What is the ratio of the Imports in Sierra Leone in 1994 to that in 1997?
Give a very brief answer. 1.28. What is the ratio of the Imports of Slovak Republic in 1994 to that in 1997?
Your response must be concise. 0.69. What is the ratio of the Imports in Haiti in 1994 to that in 1998?
Offer a terse response. 0.39. What is the ratio of the Imports in Poland in 1994 to that in 1998?
Give a very brief answer. 0.44. What is the ratio of the Imports of Sierra Leone in 1994 to that in 1998?
Ensure brevity in your answer.  1.08. What is the ratio of the Imports in Slovak Republic in 1994 to that in 1998?
Give a very brief answer. 0.7. What is the ratio of the Imports in Haiti in 1994 to that in 1999?
Your answer should be compact. 0.32. What is the ratio of the Imports of Poland in 1994 to that in 1999?
Offer a very short reply. 0.43. What is the ratio of the Imports in Sierra Leone in 1994 to that in 1999?
Give a very brief answer. 1.22. What is the ratio of the Imports of Slovak Republic in 1994 to that in 1999?
Make the answer very short. 0.73. What is the ratio of the Imports in Haiti in 1994 to that in 2000?
Offer a terse response. 0.25. What is the ratio of the Imports of Poland in 1994 to that in 2000?
Your response must be concise. 0.37. What is the ratio of the Imports in Sierra Leone in 1994 to that in 2000?
Your answer should be very brief. 0.77. What is the ratio of the Imports in Slovak Republic in 1994 to that in 2000?
Give a very brief answer. 0.68. What is the ratio of the Imports of Haiti in 1994 to that in 2001?
Provide a short and direct response. 0.25. What is the ratio of the Imports in Poland in 1994 to that in 2001?
Give a very brief answer. 0.4. What is the ratio of the Imports of Sierra Leone in 1994 to that in 2001?
Your response must be concise. 0.51. What is the ratio of the Imports in Slovak Republic in 1994 to that in 2001?
Your answer should be compact. 0.57. What is the ratio of the Imports in Haiti in 1995 to that in 1996?
Offer a terse response. 0.75. What is the ratio of the Imports in Poland in 1995 to that in 1996?
Give a very brief answer. 0.78. What is the ratio of the Imports of Sierra Leone in 1995 to that in 1996?
Ensure brevity in your answer.  0.59. What is the ratio of the Imports in Slovak Republic in 1995 to that in 1996?
Your answer should be very brief. 0.85. What is the ratio of the Imports in Haiti in 1995 to that in 1997?
Your answer should be very brief. 0.7. What is the ratio of the Imports of Poland in 1995 to that in 1997?
Your response must be concise. 0.64. What is the ratio of the Imports in Sierra Leone in 1995 to that in 1997?
Your response must be concise. 1.29. What is the ratio of the Imports in Slovak Republic in 1995 to that in 1997?
Your answer should be compact. 0.77. What is the ratio of the Imports in Haiti in 1995 to that in 1998?
Give a very brief answer. 0.66. What is the ratio of the Imports of Poland in 1995 to that in 1998?
Make the answer very short. 0.54. What is the ratio of the Imports in Sierra Leone in 1995 to that in 1998?
Give a very brief answer. 1.09. What is the ratio of the Imports of Slovak Republic in 1995 to that in 1998?
Your response must be concise. 0.78. What is the ratio of the Imports of Haiti in 1995 to that in 1999?
Offer a very short reply. 0.54. What is the ratio of the Imports of Poland in 1995 to that in 1999?
Keep it short and to the point. 0.54. What is the ratio of the Imports in Sierra Leone in 1995 to that in 1999?
Your answer should be very brief. 1.23. What is the ratio of the Imports of Slovak Republic in 1995 to that in 1999?
Provide a succinct answer. 0.81. What is the ratio of the Imports in Haiti in 1995 to that in 2000?
Ensure brevity in your answer.  0.42. What is the ratio of the Imports of Poland in 1995 to that in 2000?
Offer a terse response. 0.46. What is the ratio of the Imports in Sierra Leone in 1995 to that in 2000?
Keep it short and to the point. 0.78. What is the ratio of the Imports of Slovak Republic in 1995 to that in 2000?
Provide a short and direct response. 0.76. What is the ratio of the Imports in Haiti in 1995 to that in 2001?
Give a very brief answer. 0.42. What is the ratio of the Imports in Poland in 1995 to that in 2001?
Make the answer very short. 0.49. What is the ratio of the Imports of Sierra Leone in 1995 to that in 2001?
Ensure brevity in your answer.  0.51. What is the ratio of the Imports in Slovak Republic in 1995 to that in 2001?
Your answer should be compact. 0.64. What is the ratio of the Imports in Haiti in 1996 to that in 1997?
Keep it short and to the point. 0.93. What is the ratio of the Imports in Poland in 1996 to that in 1997?
Provide a short and direct response. 0.82. What is the ratio of the Imports in Sierra Leone in 1996 to that in 1997?
Your answer should be very brief. 2.19. What is the ratio of the Imports in Slovak Republic in 1996 to that in 1997?
Provide a succinct answer. 0.91. What is the ratio of the Imports of Poland in 1996 to that in 1998?
Provide a succinct answer. 0.69. What is the ratio of the Imports in Sierra Leone in 1996 to that in 1998?
Provide a short and direct response. 1.85. What is the ratio of the Imports of Slovak Republic in 1996 to that in 1998?
Keep it short and to the point. 0.92. What is the ratio of the Imports of Haiti in 1996 to that in 1999?
Give a very brief answer. 0.71. What is the ratio of the Imports of Poland in 1996 to that in 1999?
Your answer should be very brief. 0.69. What is the ratio of the Imports of Sierra Leone in 1996 to that in 1999?
Keep it short and to the point. 2.07. What is the ratio of the Imports in Haiti in 1996 to that in 2000?
Give a very brief answer. 0.55. What is the ratio of the Imports in Poland in 1996 to that in 2000?
Ensure brevity in your answer.  0.6. What is the ratio of the Imports in Sierra Leone in 1996 to that in 2000?
Offer a terse response. 1.31. What is the ratio of the Imports in Slovak Republic in 1996 to that in 2000?
Keep it short and to the point. 0.89. What is the ratio of the Imports in Haiti in 1996 to that in 2001?
Keep it short and to the point. 0.56. What is the ratio of the Imports in Poland in 1996 to that in 2001?
Offer a very short reply. 0.63. What is the ratio of the Imports in Sierra Leone in 1996 to that in 2001?
Provide a succinct answer. 0.87. What is the ratio of the Imports of Slovak Republic in 1996 to that in 2001?
Provide a short and direct response. 0.75. What is the ratio of the Imports in Haiti in 1997 to that in 1998?
Offer a very short reply. 0.94. What is the ratio of the Imports in Poland in 1997 to that in 1998?
Make the answer very short. 0.84. What is the ratio of the Imports in Sierra Leone in 1997 to that in 1998?
Ensure brevity in your answer.  0.84. What is the ratio of the Imports of Slovak Republic in 1997 to that in 1998?
Provide a short and direct response. 1.01. What is the ratio of the Imports in Haiti in 1997 to that in 1999?
Provide a succinct answer. 0.76. What is the ratio of the Imports in Poland in 1997 to that in 1999?
Provide a succinct answer. 0.83. What is the ratio of the Imports of Sierra Leone in 1997 to that in 1999?
Your answer should be very brief. 0.95. What is the ratio of the Imports of Slovak Republic in 1997 to that in 1999?
Your answer should be compact. 1.05. What is the ratio of the Imports of Haiti in 1997 to that in 2000?
Your answer should be very brief. 0.59. What is the ratio of the Imports in Poland in 1997 to that in 2000?
Your answer should be very brief. 0.72. What is the ratio of the Imports in Sierra Leone in 1997 to that in 2000?
Your answer should be compact. 0.6. What is the ratio of the Imports in Slovak Republic in 1997 to that in 2000?
Offer a very short reply. 0.98. What is the ratio of the Imports in Haiti in 1997 to that in 2001?
Keep it short and to the point. 0.6. What is the ratio of the Imports in Poland in 1997 to that in 2001?
Give a very brief answer. 0.76. What is the ratio of the Imports in Sierra Leone in 1997 to that in 2001?
Your answer should be compact. 0.4. What is the ratio of the Imports of Slovak Republic in 1997 to that in 2001?
Ensure brevity in your answer.  0.83. What is the ratio of the Imports of Haiti in 1998 to that in 1999?
Your response must be concise. 0.81. What is the ratio of the Imports in Poland in 1998 to that in 1999?
Your answer should be compact. 0.99. What is the ratio of the Imports in Sierra Leone in 1998 to that in 1999?
Make the answer very short. 1.12. What is the ratio of the Imports in Slovak Republic in 1998 to that in 1999?
Your answer should be compact. 1.04. What is the ratio of the Imports in Haiti in 1998 to that in 2000?
Keep it short and to the point. 0.63. What is the ratio of the Imports of Poland in 1998 to that in 2000?
Offer a very short reply. 0.86. What is the ratio of the Imports of Sierra Leone in 1998 to that in 2000?
Provide a short and direct response. 0.71. What is the ratio of the Imports in Slovak Republic in 1998 to that in 2000?
Your answer should be compact. 0.97. What is the ratio of the Imports in Haiti in 1998 to that in 2001?
Provide a succinct answer. 0.64. What is the ratio of the Imports of Poland in 1998 to that in 2001?
Offer a terse response. 0.9. What is the ratio of the Imports of Sierra Leone in 1998 to that in 2001?
Make the answer very short. 0.47. What is the ratio of the Imports of Slovak Republic in 1998 to that in 2001?
Make the answer very short. 0.82. What is the ratio of the Imports in Haiti in 1999 to that in 2000?
Give a very brief answer. 0.77. What is the ratio of the Imports of Poland in 1999 to that in 2000?
Your answer should be very brief. 0.87. What is the ratio of the Imports of Sierra Leone in 1999 to that in 2000?
Your answer should be compact. 0.63. What is the ratio of the Imports of Slovak Republic in 1999 to that in 2000?
Provide a succinct answer. 0.94. What is the ratio of the Imports in Haiti in 1999 to that in 2001?
Provide a succinct answer. 0.79. What is the ratio of the Imports in Poland in 1999 to that in 2001?
Give a very brief answer. 0.91. What is the ratio of the Imports in Sierra Leone in 1999 to that in 2001?
Provide a succinct answer. 0.42. What is the ratio of the Imports in Slovak Republic in 1999 to that in 2001?
Give a very brief answer. 0.79. What is the ratio of the Imports of Haiti in 2000 to that in 2001?
Provide a short and direct response. 1.02. What is the ratio of the Imports in Poland in 2000 to that in 2001?
Offer a terse response. 1.06. What is the ratio of the Imports of Sierra Leone in 2000 to that in 2001?
Offer a terse response. 0.66. What is the ratio of the Imports of Slovak Republic in 2000 to that in 2001?
Provide a short and direct response. 0.84. What is the difference between the highest and the second highest Imports of Haiti?
Your answer should be compact. 3.17e+08. What is the difference between the highest and the second highest Imports in Poland?
Your answer should be compact. 1.54e+1. What is the difference between the highest and the second highest Imports in Sierra Leone?
Ensure brevity in your answer.  1.42e+11. What is the difference between the highest and the second highest Imports of Slovak Republic?
Offer a terse response. 4.14e+09. What is the difference between the highest and the lowest Imports of Haiti?
Offer a terse response. 1.15e+1. What is the difference between the highest and the lowest Imports of Poland?
Offer a terse response. 1.80e+11. What is the difference between the highest and the lowest Imports of Sierra Leone?
Offer a terse response. 6.36e+11. What is the difference between the highest and the lowest Imports of Slovak Republic?
Provide a succinct answer. 1.11e+1. 